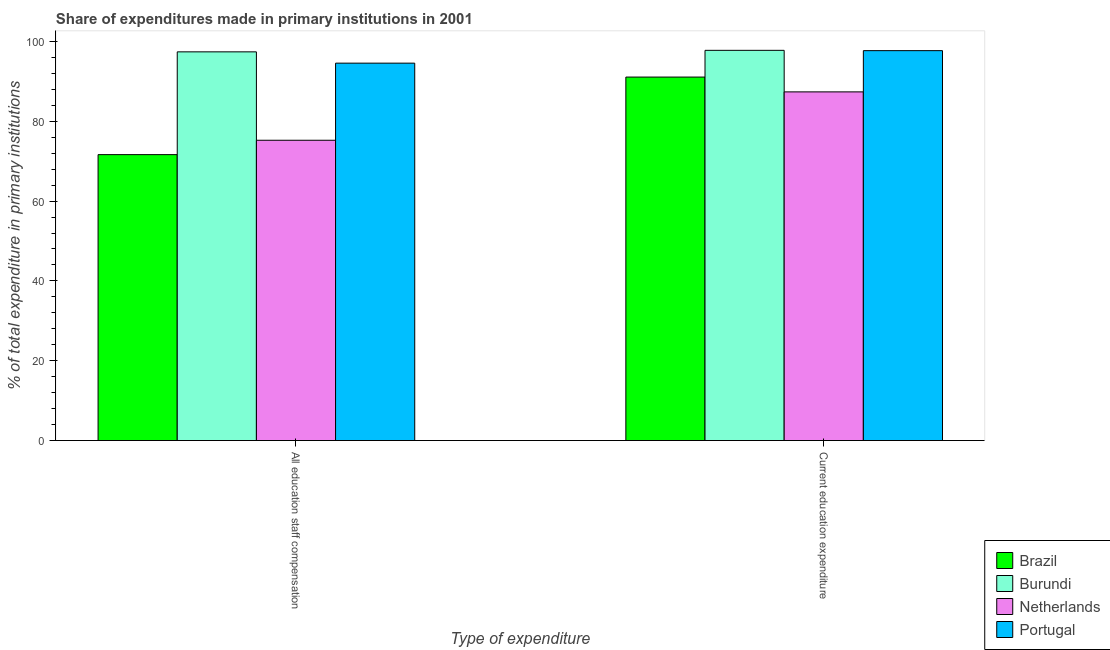How many bars are there on the 1st tick from the right?
Make the answer very short. 4. What is the label of the 2nd group of bars from the left?
Keep it short and to the point. Current education expenditure. What is the expenditure in staff compensation in Portugal?
Ensure brevity in your answer.  94.56. Across all countries, what is the maximum expenditure in staff compensation?
Ensure brevity in your answer.  97.4. Across all countries, what is the minimum expenditure in staff compensation?
Give a very brief answer. 71.64. In which country was the expenditure in staff compensation maximum?
Provide a succinct answer. Burundi. In which country was the expenditure in staff compensation minimum?
Your answer should be very brief. Brazil. What is the total expenditure in education in the graph?
Offer a terse response. 373.91. What is the difference between the expenditure in staff compensation in Portugal and that in Netherlands?
Give a very brief answer. 19.32. What is the difference between the expenditure in staff compensation in Brazil and the expenditure in education in Burundi?
Your answer should be very brief. -26.13. What is the average expenditure in education per country?
Offer a terse response. 93.48. What is the difference between the expenditure in staff compensation and expenditure in education in Burundi?
Give a very brief answer. -0.38. What is the ratio of the expenditure in education in Brazil to that in Portugal?
Provide a succinct answer. 0.93. Is the expenditure in education in Netherlands less than that in Burundi?
Offer a very short reply. Yes. In how many countries, is the expenditure in staff compensation greater than the average expenditure in staff compensation taken over all countries?
Your answer should be compact. 2. What does the 2nd bar from the left in Current education expenditure represents?
Provide a succinct answer. Burundi. What does the 3rd bar from the right in All education staff compensation represents?
Offer a terse response. Burundi. How many bars are there?
Keep it short and to the point. 8. How many countries are there in the graph?
Provide a succinct answer. 4. Does the graph contain any zero values?
Make the answer very short. No. How are the legend labels stacked?
Make the answer very short. Vertical. What is the title of the graph?
Your response must be concise. Share of expenditures made in primary institutions in 2001. What is the label or title of the X-axis?
Offer a terse response. Type of expenditure. What is the label or title of the Y-axis?
Offer a very short reply. % of total expenditure in primary institutions. What is the % of total expenditure in primary institutions in Brazil in All education staff compensation?
Your answer should be compact. 71.64. What is the % of total expenditure in primary institutions in Burundi in All education staff compensation?
Offer a very short reply. 97.4. What is the % of total expenditure in primary institutions of Netherlands in All education staff compensation?
Your response must be concise. 75.25. What is the % of total expenditure in primary institutions in Portugal in All education staff compensation?
Make the answer very short. 94.56. What is the % of total expenditure in primary institutions in Brazil in Current education expenditure?
Offer a very short reply. 91.08. What is the % of total expenditure in primary institutions in Burundi in Current education expenditure?
Offer a terse response. 97.77. What is the % of total expenditure in primary institutions in Netherlands in Current education expenditure?
Provide a short and direct response. 87.36. What is the % of total expenditure in primary institutions in Portugal in Current education expenditure?
Ensure brevity in your answer.  97.7. Across all Type of expenditure, what is the maximum % of total expenditure in primary institutions in Brazil?
Make the answer very short. 91.08. Across all Type of expenditure, what is the maximum % of total expenditure in primary institutions in Burundi?
Offer a terse response. 97.77. Across all Type of expenditure, what is the maximum % of total expenditure in primary institutions of Netherlands?
Offer a terse response. 87.36. Across all Type of expenditure, what is the maximum % of total expenditure in primary institutions of Portugal?
Offer a very short reply. 97.7. Across all Type of expenditure, what is the minimum % of total expenditure in primary institutions in Brazil?
Offer a very short reply. 71.64. Across all Type of expenditure, what is the minimum % of total expenditure in primary institutions of Burundi?
Your answer should be compact. 97.4. Across all Type of expenditure, what is the minimum % of total expenditure in primary institutions of Netherlands?
Your response must be concise. 75.25. Across all Type of expenditure, what is the minimum % of total expenditure in primary institutions in Portugal?
Provide a succinct answer. 94.56. What is the total % of total expenditure in primary institutions in Brazil in the graph?
Your response must be concise. 162.72. What is the total % of total expenditure in primary institutions of Burundi in the graph?
Your response must be concise. 195.17. What is the total % of total expenditure in primary institutions in Netherlands in the graph?
Your answer should be very brief. 162.61. What is the total % of total expenditure in primary institutions in Portugal in the graph?
Offer a very short reply. 192.26. What is the difference between the % of total expenditure in primary institutions of Brazil in All education staff compensation and that in Current education expenditure?
Offer a terse response. -19.43. What is the difference between the % of total expenditure in primary institutions in Burundi in All education staff compensation and that in Current education expenditure?
Your answer should be very brief. -0.38. What is the difference between the % of total expenditure in primary institutions of Netherlands in All education staff compensation and that in Current education expenditure?
Your response must be concise. -12.12. What is the difference between the % of total expenditure in primary institutions in Portugal in All education staff compensation and that in Current education expenditure?
Give a very brief answer. -3.13. What is the difference between the % of total expenditure in primary institutions of Brazil in All education staff compensation and the % of total expenditure in primary institutions of Burundi in Current education expenditure?
Your response must be concise. -26.13. What is the difference between the % of total expenditure in primary institutions in Brazil in All education staff compensation and the % of total expenditure in primary institutions in Netherlands in Current education expenditure?
Make the answer very short. -15.72. What is the difference between the % of total expenditure in primary institutions in Brazil in All education staff compensation and the % of total expenditure in primary institutions in Portugal in Current education expenditure?
Ensure brevity in your answer.  -26.05. What is the difference between the % of total expenditure in primary institutions in Burundi in All education staff compensation and the % of total expenditure in primary institutions in Netherlands in Current education expenditure?
Offer a terse response. 10.03. What is the difference between the % of total expenditure in primary institutions in Burundi in All education staff compensation and the % of total expenditure in primary institutions in Portugal in Current education expenditure?
Make the answer very short. -0.3. What is the difference between the % of total expenditure in primary institutions in Netherlands in All education staff compensation and the % of total expenditure in primary institutions in Portugal in Current education expenditure?
Give a very brief answer. -22.45. What is the average % of total expenditure in primary institutions of Brazil per Type of expenditure?
Your answer should be compact. 81.36. What is the average % of total expenditure in primary institutions in Burundi per Type of expenditure?
Give a very brief answer. 97.59. What is the average % of total expenditure in primary institutions in Netherlands per Type of expenditure?
Provide a succinct answer. 81.31. What is the average % of total expenditure in primary institutions of Portugal per Type of expenditure?
Your answer should be very brief. 96.13. What is the difference between the % of total expenditure in primary institutions in Brazil and % of total expenditure in primary institutions in Burundi in All education staff compensation?
Offer a terse response. -25.75. What is the difference between the % of total expenditure in primary institutions of Brazil and % of total expenditure in primary institutions of Netherlands in All education staff compensation?
Make the answer very short. -3.6. What is the difference between the % of total expenditure in primary institutions of Brazil and % of total expenditure in primary institutions of Portugal in All education staff compensation?
Provide a short and direct response. -22.92. What is the difference between the % of total expenditure in primary institutions of Burundi and % of total expenditure in primary institutions of Netherlands in All education staff compensation?
Make the answer very short. 22.15. What is the difference between the % of total expenditure in primary institutions of Burundi and % of total expenditure in primary institutions of Portugal in All education staff compensation?
Your answer should be very brief. 2.83. What is the difference between the % of total expenditure in primary institutions of Netherlands and % of total expenditure in primary institutions of Portugal in All education staff compensation?
Your answer should be very brief. -19.32. What is the difference between the % of total expenditure in primary institutions in Brazil and % of total expenditure in primary institutions in Burundi in Current education expenditure?
Make the answer very short. -6.7. What is the difference between the % of total expenditure in primary institutions in Brazil and % of total expenditure in primary institutions in Netherlands in Current education expenditure?
Your answer should be very brief. 3.71. What is the difference between the % of total expenditure in primary institutions in Brazil and % of total expenditure in primary institutions in Portugal in Current education expenditure?
Give a very brief answer. -6.62. What is the difference between the % of total expenditure in primary institutions of Burundi and % of total expenditure in primary institutions of Netherlands in Current education expenditure?
Offer a very short reply. 10.41. What is the difference between the % of total expenditure in primary institutions of Burundi and % of total expenditure in primary institutions of Portugal in Current education expenditure?
Offer a very short reply. 0.08. What is the difference between the % of total expenditure in primary institutions in Netherlands and % of total expenditure in primary institutions in Portugal in Current education expenditure?
Keep it short and to the point. -10.33. What is the ratio of the % of total expenditure in primary institutions of Brazil in All education staff compensation to that in Current education expenditure?
Your response must be concise. 0.79. What is the ratio of the % of total expenditure in primary institutions of Burundi in All education staff compensation to that in Current education expenditure?
Provide a short and direct response. 1. What is the ratio of the % of total expenditure in primary institutions of Netherlands in All education staff compensation to that in Current education expenditure?
Keep it short and to the point. 0.86. What is the ratio of the % of total expenditure in primary institutions of Portugal in All education staff compensation to that in Current education expenditure?
Provide a succinct answer. 0.97. What is the difference between the highest and the second highest % of total expenditure in primary institutions in Brazil?
Offer a very short reply. 19.43. What is the difference between the highest and the second highest % of total expenditure in primary institutions in Burundi?
Provide a succinct answer. 0.38. What is the difference between the highest and the second highest % of total expenditure in primary institutions of Netherlands?
Provide a succinct answer. 12.12. What is the difference between the highest and the second highest % of total expenditure in primary institutions in Portugal?
Provide a short and direct response. 3.13. What is the difference between the highest and the lowest % of total expenditure in primary institutions of Brazil?
Make the answer very short. 19.43. What is the difference between the highest and the lowest % of total expenditure in primary institutions in Burundi?
Offer a very short reply. 0.38. What is the difference between the highest and the lowest % of total expenditure in primary institutions in Netherlands?
Your answer should be compact. 12.12. What is the difference between the highest and the lowest % of total expenditure in primary institutions in Portugal?
Ensure brevity in your answer.  3.13. 